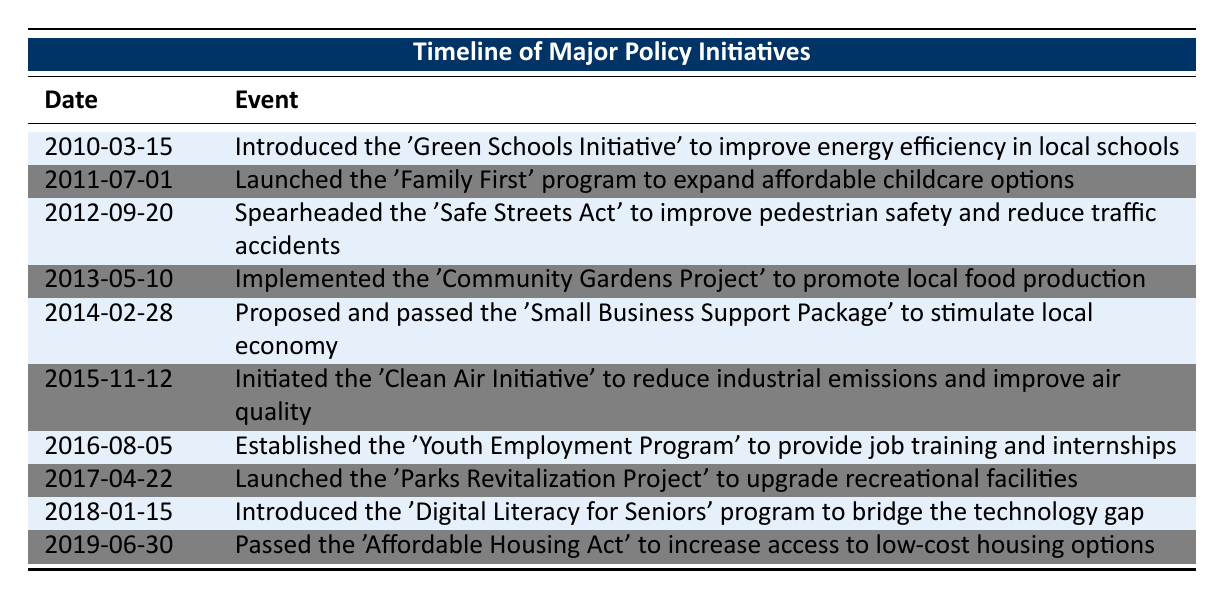What initiative was introduced in March 2010? The table shows that on March 15, 2010, the 'Green Schools Initiative' was introduced to improve energy efficiency in local schools.
Answer: Green Schools Initiative Which program was launched in July 2011? Referring to the table, the 'Family First' program was launched on July 1, 2011, to expand affordable childcare options.
Answer: Family First program How many initiatives aimed at helping youth were introduced? By examining the events in the table, the 'Youth Employment Program' established in August 2016 is the only initiative specifically aimed at helping youth.
Answer: 1 Was the 'Clean Air Initiative' passed before the 'Affordable Housing Act'? Looking at the dates, the 'Clean Air Initiative' was initiated on November 12, 2015, and the 'Affordable Housing Act' was passed on June 30, 2019. Since November 2015 is before June 2019, the statement is true.
Answer: Yes Count how many initiatives were launched in the years 2010 to 2015. The initiatives within this range include the 'Green Schools Initiative' (2010), 'Family First' program (2011), 'Safe Streets Act' (2012), 'Community Gardens Project' (2013), 'Small Business Support Package' (2014), and 'Clean Air Initiative' (2015). That makes a total of 6 initiatives.
Answer: 6 What is the median date of the initiatives listed in the table? There are 10 dates total. Sorting them gives us the formative dates: 2010-03-15, 2011-07-01, 2012-09-20, 2013-05-10, 2014-02-28, 2015-11-12, 2016-08-05, 2017-04-22, 2018-01-15, and 2019-06-30. The median, the average of the 5th and 6th entries, is between 2015-11-12 and 2016-08-05, which calculates to 2016-02-09.
Answer: 2016-02-09 What event involved job training and when was it initiated? According to the table, the 'Youth Employment Program' involved job training and was established on August 5, 2016.
Answer: Youth Employment Program, August 5, 2016 Did any initiative address environmental concerns? Reviewing the table, the 'Clean Air Initiative' was specifically initiated to reduce industrial emissions and improve air quality, which directly addresses environmental concerns.
Answer: Yes Which two initiatives were associated with improving safety and community wellness? The initiatives that focus on safety and community wellness are the 'Safe Streets Act' (pedestrian safety) introduced on September 20, 2012, and the 'Community Gardens Project' (promoting local food production) implemented on May 10, 2013.
Answer: Safe Streets Act and Community Gardens Project 